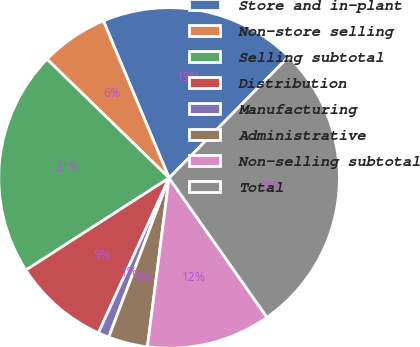Convert chart. <chart><loc_0><loc_0><loc_500><loc_500><pie_chart><fcel>Store and in-plant<fcel>Non-store selling<fcel>Selling subtotal<fcel>Distribution<fcel>Manufacturing<fcel>Administrative<fcel>Non-selling subtotal<fcel>Total<nl><fcel>18.69%<fcel>6.41%<fcel>21.38%<fcel>9.09%<fcel>1.05%<fcel>3.73%<fcel>11.78%<fcel>27.87%<nl></chart> 